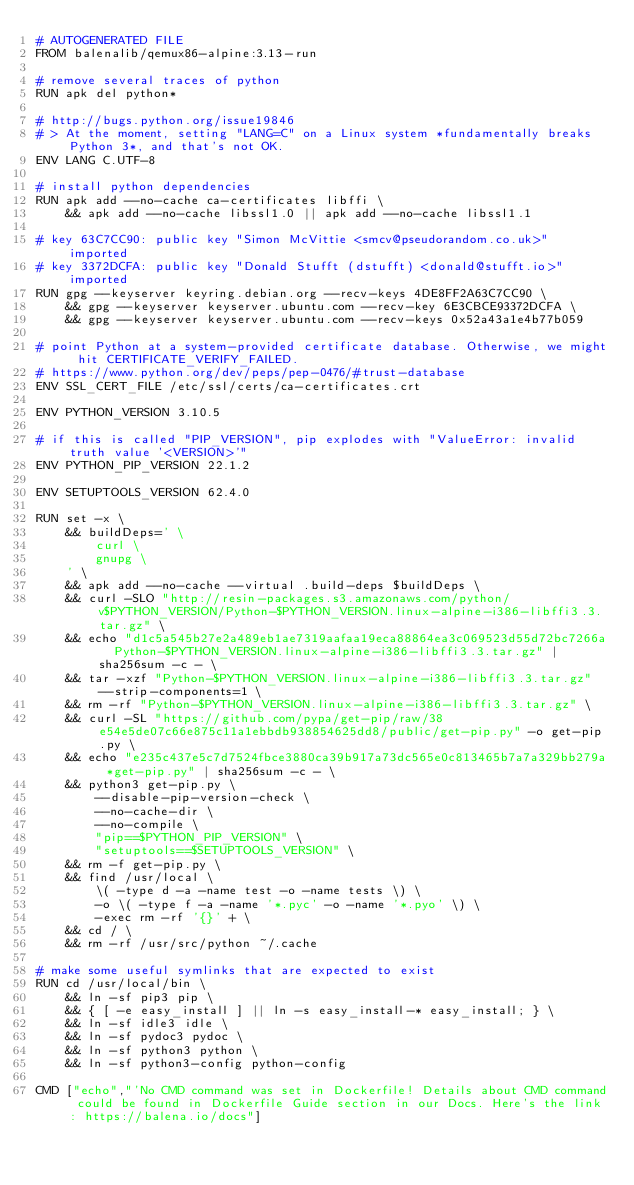<code> <loc_0><loc_0><loc_500><loc_500><_Dockerfile_># AUTOGENERATED FILE
FROM balenalib/qemux86-alpine:3.13-run

# remove several traces of python
RUN apk del python*

# http://bugs.python.org/issue19846
# > At the moment, setting "LANG=C" on a Linux system *fundamentally breaks Python 3*, and that's not OK.
ENV LANG C.UTF-8

# install python dependencies
RUN apk add --no-cache ca-certificates libffi \
	&& apk add --no-cache libssl1.0 || apk add --no-cache libssl1.1

# key 63C7CC90: public key "Simon McVittie <smcv@pseudorandom.co.uk>" imported
# key 3372DCFA: public key "Donald Stufft (dstufft) <donald@stufft.io>" imported
RUN gpg --keyserver keyring.debian.org --recv-keys 4DE8FF2A63C7CC90 \
	&& gpg --keyserver keyserver.ubuntu.com --recv-key 6E3CBCE93372DCFA \
	&& gpg --keyserver keyserver.ubuntu.com --recv-keys 0x52a43a1e4b77b059

# point Python at a system-provided certificate database. Otherwise, we might hit CERTIFICATE_VERIFY_FAILED.
# https://www.python.org/dev/peps/pep-0476/#trust-database
ENV SSL_CERT_FILE /etc/ssl/certs/ca-certificates.crt

ENV PYTHON_VERSION 3.10.5

# if this is called "PIP_VERSION", pip explodes with "ValueError: invalid truth value '<VERSION>'"
ENV PYTHON_PIP_VERSION 22.1.2

ENV SETUPTOOLS_VERSION 62.4.0

RUN set -x \
	&& buildDeps=' \
		curl \
		gnupg \
	' \
	&& apk add --no-cache --virtual .build-deps $buildDeps \
	&& curl -SLO "http://resin-packages.s3.amazonaws.com/python/v$PYTHON_VERSION/Python-$PYTHON_VERSION.linux-alpine-i386-libffi3.3.tar.gz" \
	&& echo "d1c5a545b27e2a489eb1ae7319aafaa19eca88864ea3c069523d55d72bc7266a  Python-$PYTHON_VERSION.linux-alpine-i386-libffi3.3.tar.gz" | sha256sum -c - \
	&& tar -xzf "Python-$PYTHON_VERSION.linux-alpine-i386-libffi3.3.tar.gz" --strip-components=1 \
	&& rm -rf "Python-$PYTHON_VERSION.linux-alpine-i386-libffi3.3.tar.gz" \
	&& curl -SL "https://github.com/pypa/get-pip/raw/38e54e5de07c66e875c11a1ebbdb938854625dd8/public/get-pip.py" -o get-pip.py \
    && echo "e235c437e5c7d7524fbce3880ca39b917a73dc565e0c813465b7a7a329bb279a *get-pip.py" | sha256sum -c - \
    && python3 get-pip.py \
        --disable-pip-version-check \
        --no-cache-dir \
        --no-compile \
        "pip==$PYTHON_PIP_VERSION" \
        "setuptools==$SETUPTOOLS_VERSION" \
	&& rm -f get-pip.py \
	&& find /usr/local \
		\( -type d -a -name test -o -name tests \) \
		-o \( -type f -a -name '*.pyc' -o -name '*.pyo' \) \
		-exec rm -rf '{}' + \
	&& cd / \
	&& rm -rf /usr/src/python ~/.cache

# make some useful symlinks that are expected to exist
RUN cd /usr/local/bin \
	&& ln -sf pip3 pip \
	&& { [ -e easy_install ] || ln -s easy_install-* easy_install; } \
	&& ln -sf idle3 idle \
	&& ln -sf pydoc3 pydoc \
	&& ln -sf python3 python \
	&& ln -sf python3-config python-config

CMD ["echo","'No CMD command was set in Dockerfile! Details about CMD command could be found in Dockerfile Guide section in our Docs. Here's the link: https://balena.io/docs"]
</code> 